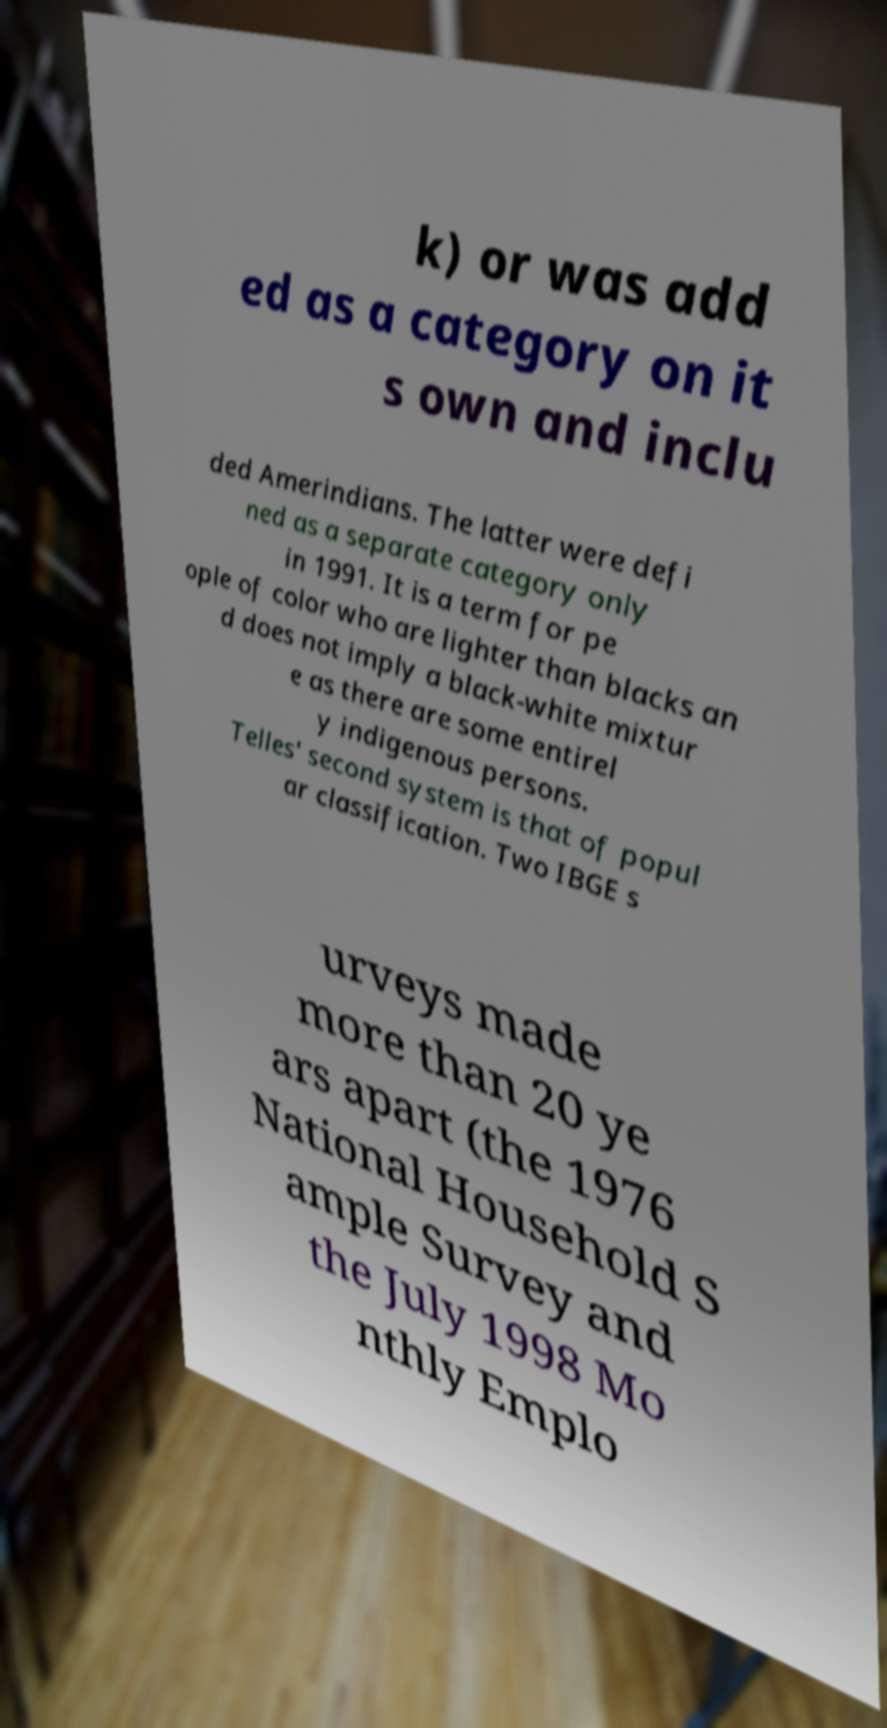There's text embedded in this image that I need extracted. Can you transcribe it verbatim? k) or was add ed as a category on it s own and inclu ded Amerindians. The latter were defi ned as a separate category only in 1991. It is a term for pe ople of color who are lighter than blacks an d does not imply a black-white mixtur e as there are some entirel y indigenous persons. Telles' second system is that of popul ar classification. Two IBGE s urveys made more than 20 ye ars apart (the 1976 National Household S ample Survey and the July 1998 Mo nthly Emplo 